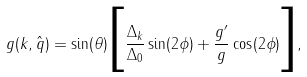Convert formula to latex. <formula><loc_0><loc_0><loc_500><loc_500>g ( { k } , \hat { q } ) = \sin ( \theta ) \Big { [ } \frac { \Delta _ { k } } { \Delta _ { 0 } } \sin ( 2 \phi ) + \frac { g ^ { \prime } } { g } \cos ( 2 \phi ) \Big { ] } ,</formula> 